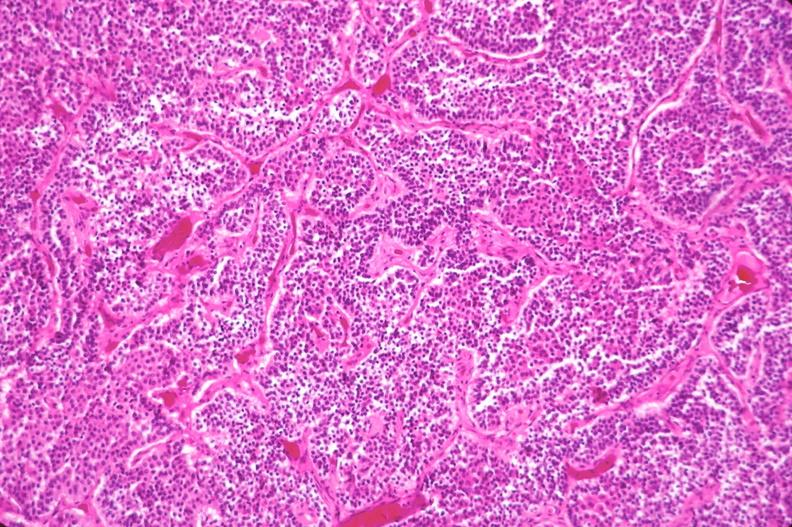s adenoma present?
Answer the question using a single word or phrase. No 